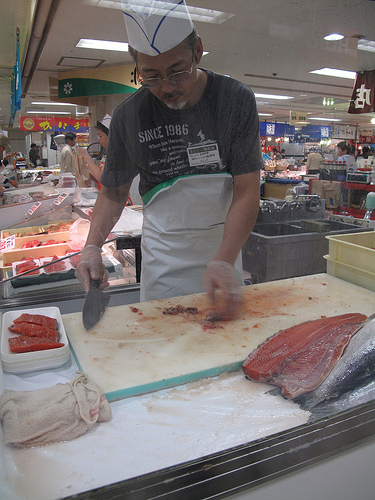<image>
Can you confirm if the hat is behind the meat? No. The hat is not behind the meat. From this viewpoint, the hat appears to be positioned elsewhere in the scene. Is the fish on the board? No. The fish is not positioned on the board. They may be near each other, but the fish is not supported by or resting on top of the board. 